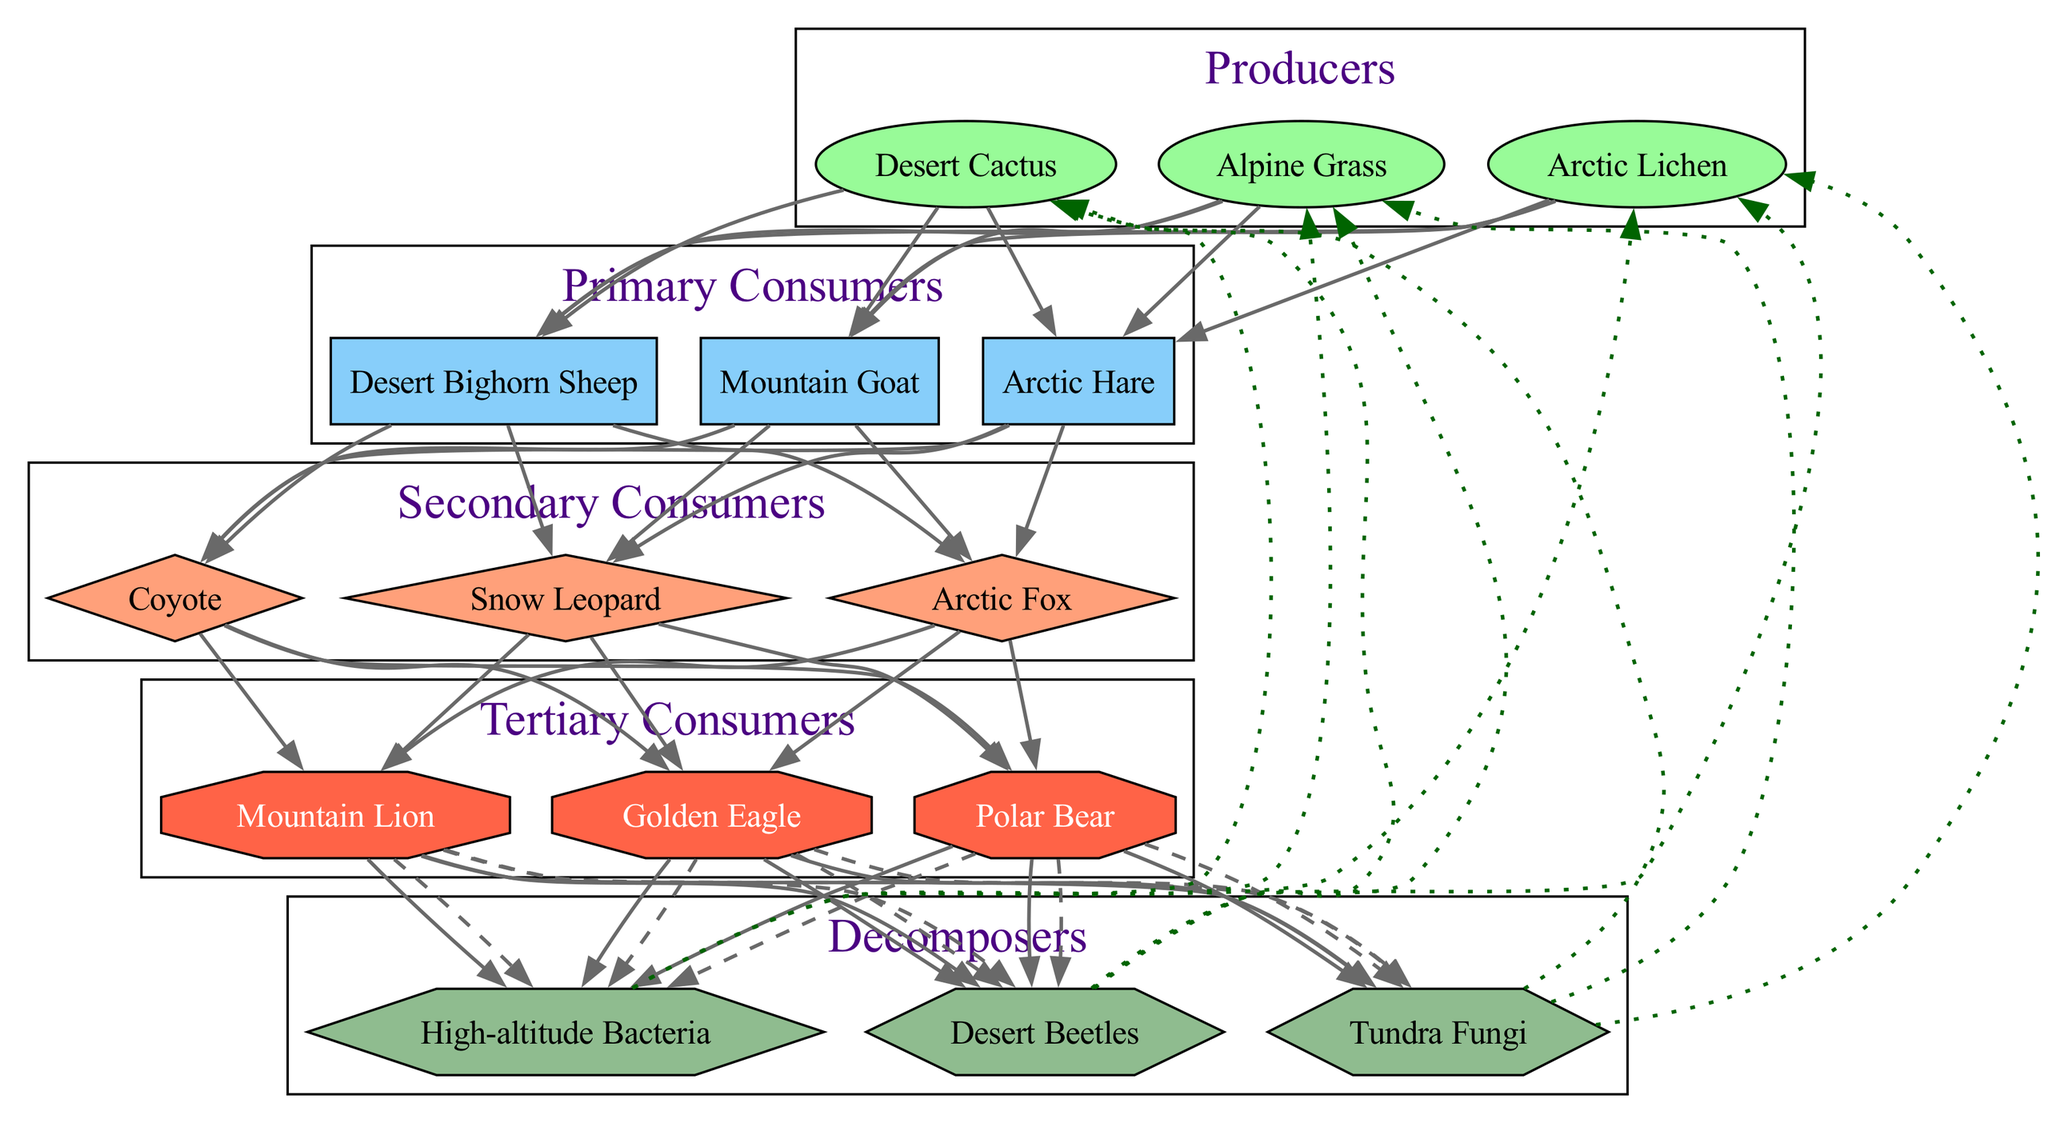What are the primary consumers in this food chain? The primary consumers can be found in the designated section of the diagram labeled "Primary Consumers." They are connected directly to the producers, indicating their role in the ecosystem. The primary consumers listed are Mountain Goat, Arctic Hare, and Desert Bighorn Sheep.
Answer: Mountain Goat, Arctic Hare, Desert Bighorn Sheep How many nodes represent tertiary consumers in the diagram? The tertiary consumers are located in a specific section labeled "Tertiary Consumers." By counting the items listed in this section, we find that there are three tertiary consumers: Golden Eagle, Polar Bear, and Mountain Lion.
Answer: 3 Who do the Arctic Hare feed on? The Arctic Hare is found in the "Primary Consumers" section of the diagram. Upon examining the directed edges leading from the primary consumers to secondary consumers, it shows that the Arctic Hare is eaten by the secondary consumers, specifically the Arctic Fox and the Snow Leopard.
Answer: Arctic Fox, Snow Leopard What is the role of High-altitude Bacteria in the food chain? High-altitude Bacteria are located in the "Decomposers" section of the diagram. They have connections leading to the producers, indicating that they contribute to nutrient cycling by breaking down organic matter from deceased organisms and enriching the soil, allowing producers to thrive.
Answer: Decomposer Which secondary consumer directly connects to the Desert Bighorn Sheep? In the diagram, the secondary consumers are placed above the primary consumers. Tracing the edges from the Desert Bighorn Sheep in the primary consumer section leads to the secondary consumer section, revealing that it connects to the Coyote.
Answer: Coyote What type of edge connects the tertiary consumers to the decomposers? The diagram depicts the relationships with specific styles. Using the visual cues, we can see that the edges from the tertiary consumers to the decomposers are dashed lines, indicating a specific relationship type, which is typical for interactions involving decomposition.
Answer: Dashed edge How many producers are present in the food chain? The producers are found in the designated section labeled "Producers." By counting the items in this section, we find three producers: Alpine Grass, Arctic Lichen, and Desert Cactus.
Answer: 3 What is the significance of the edges from decomposers to producers? The edges from decomposers to producers, marked as dotted lines in the diagram, signify the process of nutrient cycling, where decomposers like the Desert Beetles bring nutrients back to the soil, which then benefits the producers.
Answer: Nutrient cycling 